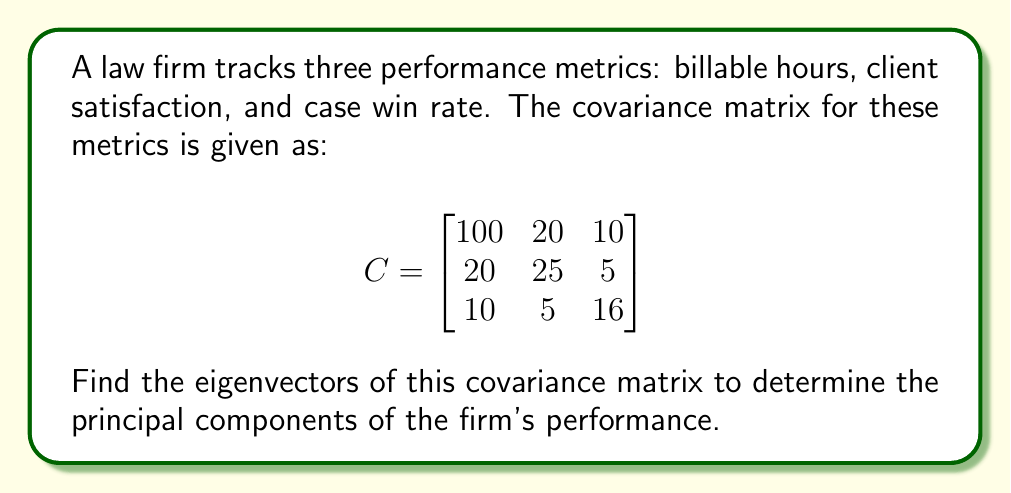Can you answer this question? To find the eigenvectors of the covariance matrix, we follow these steps:

1) First, we need to find the eigenvalues by solving the characteristic equation:
   $\det(C - \lambda I) = 0$

2) Expanding this determinant:
   $$\begin{vmatrix}
   100-\lambda & 20 & 10 \\
   20 & 25-\lambda & 5 \\
   10 & 5 & 16-\lambda
   \end{vmatrix} = 0$$

3) This gives us the characteristic polynomial:
   $-\lambda^3 + 141\lambda^2 - 5775\lambda + 70000 = 0$

4) Solving this equation (using a calculator or computer algebra system), we get the eigenvalues:
   $\lambda_1 \approx 104.88$, $\lambda_2 \approx 28.54$, $\lambda_3 \approx 7.58$

5) For each eigenvalue, we solve $(C - \lambda_i I)v_i = 0$ to find the corresponding eigenvector:

   For $\lambda_1 \approx 104.88$:
   $$\begin{bmatrix}
   -4.88 & 20 & 10 \\
   20 & -79.88 & 5 \\
   10 & 5 & -88.88
   \end{bmatrix} \begin{bmatrix} v_1 \\ v_2 \\ v_3 \end{bmatrix} = \begin{bmatrix} 0 \\ 0 \\ 0 \end{bmatrix}$$

   Solving this system gives us: $v_1 \approx [0.9397, 0.3017, 0.1609]$

   Similarly, for $\lambda_2$ and $\lambda_3$, we get:
   $v_2 \approx [-0.3306, 0.9214, -0.2068]$
   $v_3 \approx [0.0891, 0.2447, -0.9655]$

6) These eigenvectors represent the principal components of the firm's performance metrics.
Answer: $v_1 \approx [0.9397, 0.3017, 0.1609]$, $v_2 \approx [-0.3306, 0.9214, -0.2068]$, $v_3 \approx [0.0891, 0.2447, -0.9655]$ 